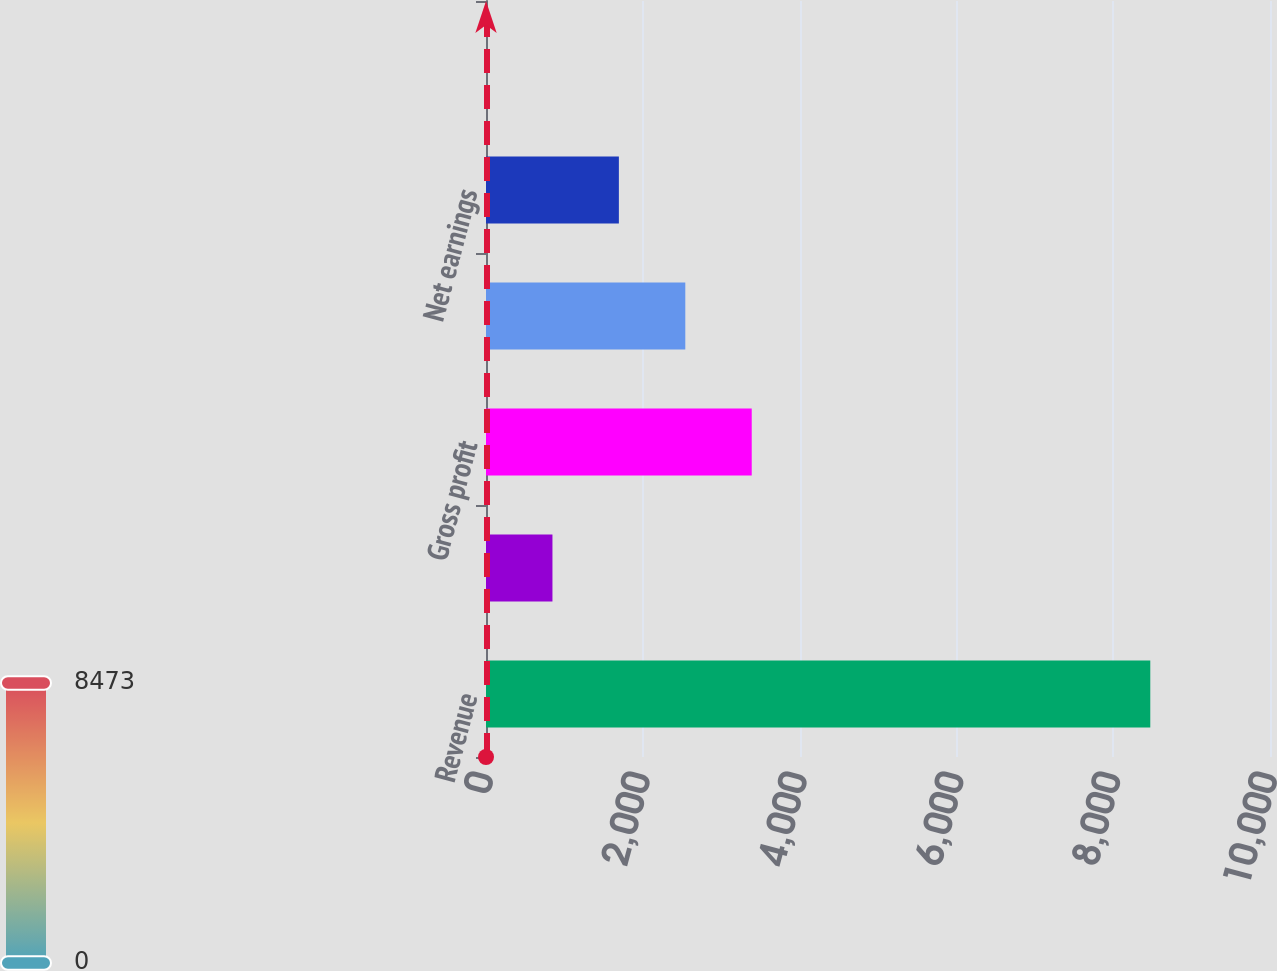<chart> <loc_0><loc_0><loc_500><loc_500><bar_chart><fcel>Revenue<fcel>Comparable store sales change<fcel>Gross profit<fcel>Operating income<fcel>Net earnings<fcel>Diluted earnings per share<nl><fcel>8473<fcel>847.58<fcel>3389.39<fcel>2542.12<fcel>1694.85<fcel>0.31<nl></chart> 